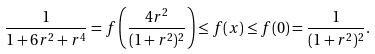Convert formula to latex. <formula><loc_0><loc_0><loc_500><loc_500>\frac { 1 } { 1 + 6 r ^ { 2 } + r ^ { 4 } } = f \left ( \frac { 4 r ^ { 2 } } { ( 1 + r ^ { 2 } ) ^ { 2 } } \right ) \leq f ( x ) \leq f ( 0 ) = \frac { 1 } { ( 1 + r ^ { 2 } ) ^ { 2 } } .</formula> 